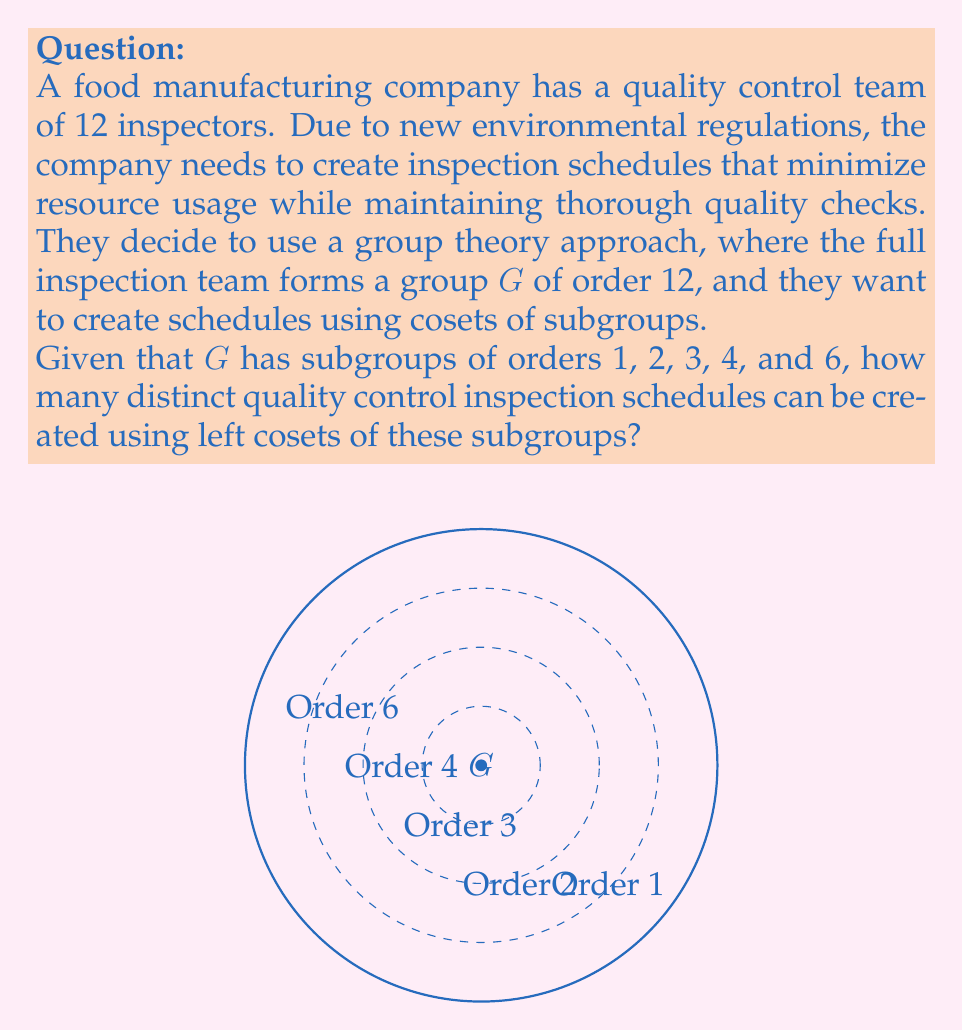Teach me how to tackle this problem. Let's approach this step-by-step:

1) For a group $G$ of order 12, the possible subgroup orders are 1, 2, 3, 4, and 6 (as given in the question).

2) For each subgroup $H$ of $G$, the number of left cosets is equal to the index of $H$ in $G$, which is given by $[G:H] = |G|/|H|$.

3) Let's calculate the number of left cosets for each subgroup order:

   - For $|H| = 1$: $[G:H] = 12/1 = 12$ cosets
   - For $|H| = 2$: $[G:H] = 12/2 = 6$ cosets
   - For $|H| = 3$: $[G:H] = 12/3 = 4$ cosets
   - For $|H| = 4$: $[G:H] = 12/4 = 3$ cosets
   - For $|H| = 6$: $[G:H] = 12/6 = 2$ cosets

4) Each set of cosets forms a distinct inspection schedule. Therefore, the total number of possible schedules is the sum of these coset counts:

   $12 + 6 + 4 + 3 + 2 = 27$

5) However, we need to consider that there might be multiple subgroups of the same order. In a group of order 12, there is:
   - 1 subgroup of order 1 (the trivial subgroup)
   - 1 subgroup of order 12 (the whole group, which we don't count as it gives only 1 coset)
   - Potentially multiple subgroups of orders 2, 3, 4, and 6

6) The exact number of subgroups depends on the specific structure of the group of order 12. Without more information, we can't determine this precisely.

Therefore, the number of distinct schedules is at least 27, but could be more depending on the number of subgroups of each order.
Answer: At least 27 distinct schedules 